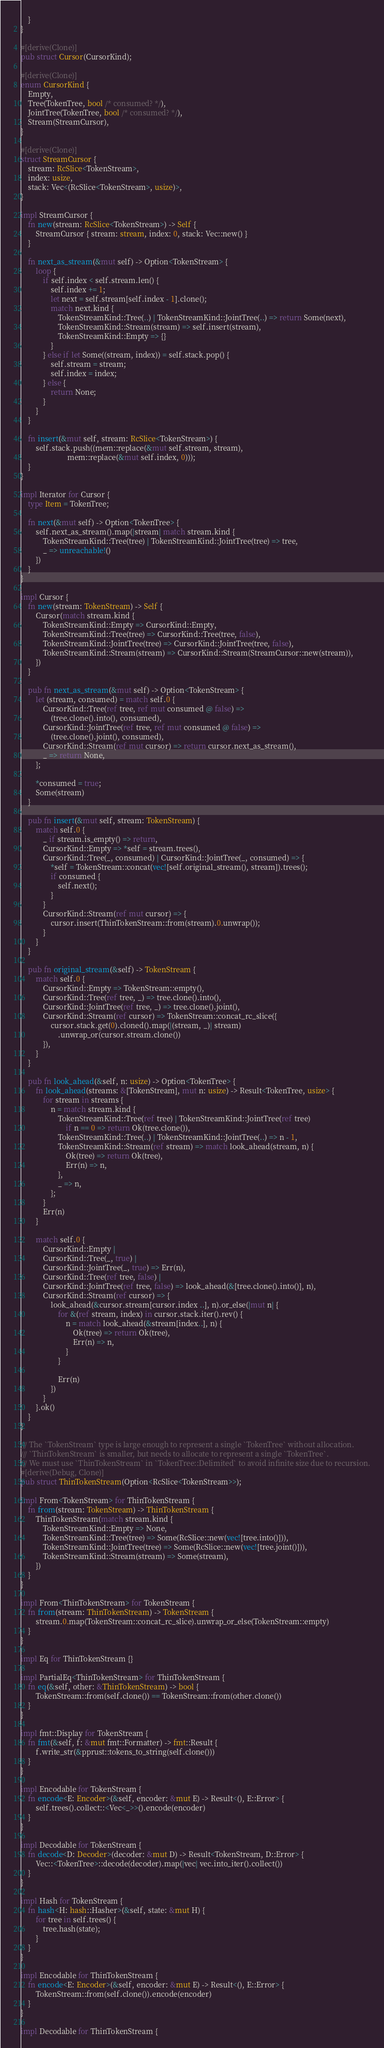Convert code to text. <code><loc_0><loc_0><loc_500><loc_500><_Rust_>    }
}

#[derive(Clone)]
pub struct Cursor(CursorKind);

#[derive(Clone)]
enum CursorKind {
    Empty,
    Tree(TokenTree, bool /* consumed? */),
    JointTree(TokenTree, bool /* consumed? */),
    Stream(StreamCursor),
}

#[derive(Clone)]
struct StreamCursor {
    stream: RcSlice<TokenStream>,
    index: usize,
    stack: Vec<(RcSlice<TokenStream>, usize)>,
}

impl StreamCursor {
    fn new(stream: RcSlice<TokenStream>) -> Self {
        StreamCursor { stream: stream, index: 0, stack: Vec::new() }
    }

    fn next_as_stream(&mut self) -> Option<TokenStream> {
        loop {
            if self.index < self.stream.len() {
                self.index += 1;
                let next = self.stream[self.index - 1].clone();
                match next.kind {
                    TokenStreamKind::Tree(..) | TokenStreamKind::JointTree(..) => return Some(next),
                    TokenStreamKind::Stream(stream) => self.insert(stream),
                    TokenStreamKind::Empty => {}
                }
            } else if let Some((stream, index)) = self.stack.pop() {
                self.stream = stream;
                self.index = index;
            } else {
                return None;
            }
        }
    }

    fn insert(&mut self, stream: RcSlice<TokenStream>) {
        self.stack.push((mem::replace(&mut self.stream, stream),
                         mem::replace(&mut self.index, 0)));
    }
}

impl Iterator for Cursor {
    type Item = TokenTree;

    fn next(&mut self) -> Option<TokenTree> {
        self.next_as_stream().map(|stream| match stream.kind {
            TokenStreamKind::Tree(tree) | TokenStreamKind::JointTree(tree) => tree,
            _ => unreachable!()
        })
    }
}

impl Cursor {
    fn new(stream: TokenStream) -> Self {
        Cursor(match stream.kind {
            TokenStreamKind::Empty => CursorKind::Empty,
            TokenStreamKind::Tree(tree) => CursorKind::Tree(tree, false),
            TokenStreamKind::JointTree(tree) => CursorKind::JointTree(tree, false),
            TokenStreamKind::Stream(stream) => CursorKind::Stream(StreamCursor::new(stream)),
        })
    }

    pub fn next_as_stream(&mut self) -> Option<TokenStream> {
        let (stream, consumed) = match self.0 {
            CursorKind::Tree(ref tree, ref mut consumed @ false) =>
                (tree.clone().into(), consumed),
            CursorKind::JointTree(ref tree, ref mut consumed @ false) =>
                (tree.clone().joint(), consumed),
            CursorKind::Stream(ref mut cursor) => return cursor.next_as_stream(),
            _ => return None,
        };

        *consumed = true;
        Some(stream)
    }

    pub fn insert(&mut self, stream: TokenStream) {
        match self.0 {
            _ if stream.is_empty() => return,
            CursorKind::Empty => *self = stream.trees(),
            CursorKind::Tree(_, consumed) | CursorKind::JointTree(_, consumed) => {
                *self = TokenStream::concat(vec![self.original_stream(), stream]).trees();
                if consumed {
                    self.next();
                }
            }
            CursorKind::Stream(ref mut cursor) => {
                cursor.insert(ThinTokenStream::from(stream).0.unwrap());
            }
        }
    }

    pub fn original_stream(&self) -> TokenStream {
        match self.0 {
            CursorKind::Empty => TokenStream::empty(),
            CursorKind::Tree(ref tree, _) => tree.clone().into(),
            CursorKind::JointTree(ref tree, _) => tree.clone().joint(),
            CursorKind::Stream(ref cursor) => TokenStream::concat_rc_slice({
                cursor.stack.get(0).cloned().map(|(stream, _)| stream)
                    .unwrap_or(cursor.stream.clone())
            }),
        }
    }

    pub fn look_ahead(&self, n: usize) -> Option<TokenTree> {
        fn look_ahead(streams: &[TokenStream], mut n: usize) -> Result<TokenTree, usize> {
            for stream in streams {
                n = match stream.kind {
                    TokenStreamKind::Tree(ref tree) | TokenStreamKind::JointTree(ref tree)
                        if n == 0 => return Ok(tree.clone()),
                    TokenStreamKind::Tree(..) | TokenStreamKind::JointTree(..) => n - 1,
                    TokenStreamKind::Stream(ref stream) => match look_ahead(stream, n) {
                        Ok(tree) => return Ok(tree),
                        Err(n) => n,
                    },
                    _ => n,
                };
            }
            Err(n)
        }

        match self.0 {
            CursorKind::Empty |
            CursorKind::Tree(_, true) |
            CursorKind::JointTree(_, true) => Err(n),
            CursorKind::Tree(ref tree, false) |
            CursorKind::JointTree(ref tree, false) => look_ahead(&[tree.clone().into()], n),
            CursorKind::Stream(ref cursor) => {
                look_ahead(&cursor.stream[cursor.index ..], n).or_else(|mut n| {
                    for &(ref stream, index) in cursor.stack.iter().rev() {
                        n = match look_ahead(&stream[index..], n) {
                            Ok(tree) => return Ok(tree),
                            Err(n) => n,
                        }
                    }

                    Err(n)
                })
            }
        }.ok()
    }
}

/// The `TokenStream` type is large enough to represent a single `TokenTree` without allocation.
/// `ThinTokenStream` is smaller, but needs to allocate to represent a single `TokenTree`.
/// We must use `ThinTokenStream` in `TokenTree::Delimited` to avoid infinite size due to recursion.
#[derive(Debug, Clone)]
pub struct ThinTokenStream(Option<RcSlice<TokenStream>>);

impl From<TokenStream> for ThinTokenStream {
    fn from(stream: TokenStream) -> ThinTokenStream {
        ThinTokenStream(match stream.kind {
            TokenStreamKind::Empty => None,
            TokenStreamKind::Tree(tree) => Some(RcSlice::new(vec![tree.into()])),
            TokenStreamKind::JointTree(tree) => Some(RcSlice::new(vec![tree.joint()])),
            TokenStreamKind::Stream(stream) => Some(stream),
        })
    }
}

impl From<ThinTokenStream> for TokenStream {
    fn from(stream: ThinTokenStream) -> TokenStream {
        stream.0.map(TokenStream::concat_rc_slice).unwrap_or_else(TokenStream::empty)
    }
}

impl Eq for ThinTokenStream {}

impl PartialEq<ThinTokenStream> for ThinTokenStream {
    fn eq(&self, other: &ThinTokenStream) -> bool {
        TokenStream::from(self.clone()) == TokenStream::from(other.clone())
    }
}

impl fmt::Display for TokenStream {
    fn fmt(&self, f: &mut fmt::Formatter) -> fmt::Result {
        f.write_str(&pprust::tokens_to_string(self.clone()))
    }
}

impl Encodable for TokenStream {
    fn encode<E: Encoder>(&self, encoder: &mut E) -> Result<(), E::Error> {
        self.trees().collect::<Vec<_>>().encode(encoder)
    }
}

impl Decodable for TokenStream {
    fn decode<D: Decoder>(decoder: &mut D) -> Result<TokenStream, D::Error> {
        Vec::<TokenTree>::decode(decoder).map(|vec| vec.into_iter().collect())
    }
}

impl Hash for TokenStream {
    fn hash<H: hash::Hasher>(&self, state: &mut H) {
        for tree in self.trees() {
            tree.hash(state);
        }
    }
}

impl Encodable for ThinTokenStream {
    fn encode<E: Encoder>(&self, encoder: &mut E) -> Result<(), E::Error> {
        TokenStream::from(self.clone()).encode(encoder)
    }
}

impl Decodable for ThinTokenStream {</code> 